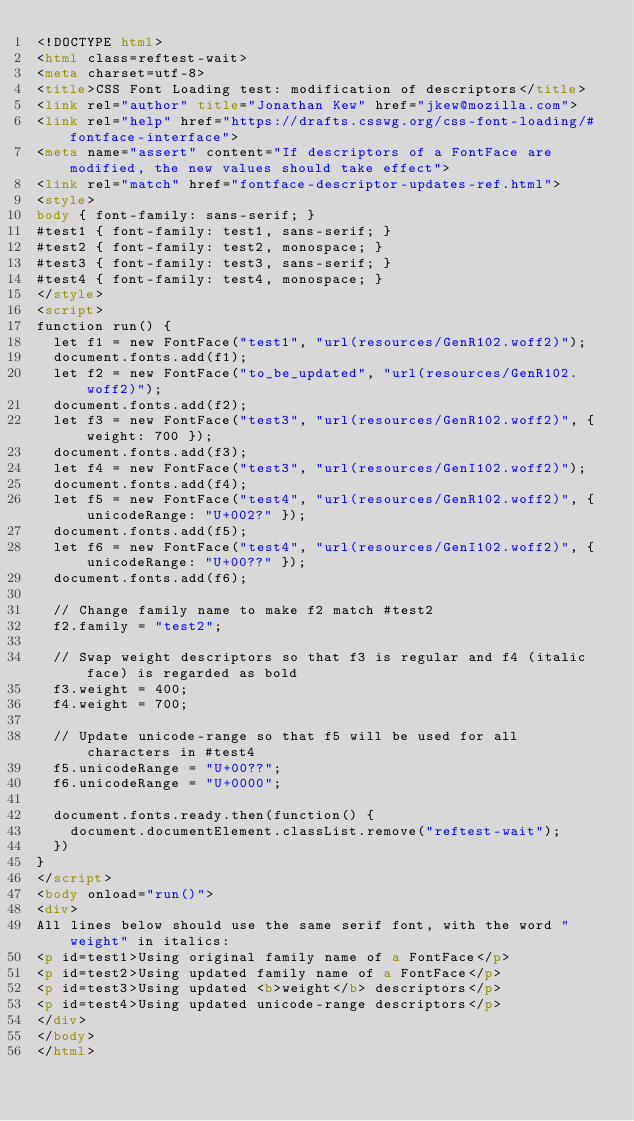<code> <loc_0><loc_0><loc_500><loc_500><_HTML_><!DOCTYPE html>
<html class=reftest-wait>
<meta charset=utf-8>
<title>CSS Font Loading test: modification of descriptors</title>
<link rel="author" title="Jonathan Kew" href="jkew@mozilla.com">
<link rel="help" href="https://drafts.csswg.org/css-font-loading/#fontface-interface">
<meta name="assert" content="If descriptors of a FontFace are modified, the new values should take effect">
<link rel="match" href="fontface-descriptor-updates-ref.html">
<style>
body { font-family: sans-serif; }
#test1 { font-family: test1, sans-serif; }
#test2 { font-family: test2, monospace; }
#test3 { font-family: test3, sans-serif; }
#test4 { font-family: test4, monospace; }
</style>
<script>
function run() {
  let f1 = new FontFace("test1", "url(resources/GenR102.woff2)");
  document.fonts.add(f1);
  let f2 = new FontFace("to_be_updated", "url(resources/GenR102.woff2)");
  document.fonts.add(f2);
  let f3 = new FontFace("test3", "url(resources/GenR102.woff2)", { weight: 700 });
  document.fonts.add(f3);
  let f4 = new FontFace("test3", "url(resources/GenI102.woff2)");
  document.fonts.add(f4);
  let f5 = new FontFace("test4", "url(resources/GenR102.woff2)", { unicodeRange: "U+002?" });
  document.fonts.add(f5);
  let f6 = new FontFace("test4", "url(resources/GenI102.woff2)", { unicodeRange: "U+00??" });
  document.fonts.add(f6);

  // Change family name to make f2 match #test2
  f2.family = "test2";

  // Swap weight descriptors so that f3 is regular and f4 (italic face) is regarded as bold
  f3.weight = 400;
  f4.weight = 700;

  // Update unicode-range so that f5 will be used for all characters in #test4
  f5.unicodeRange = "U+00??";
  f6.unicodeRange = "U+0000";

  document.fonts.ready.then(function() {
    document.documentElement.classList.remove("reftest-wait");
  })
}
</script>
<body onload="run()">
<div>
All lines below should use the same serif font, with the word "weight" in italics:
<p id=test1>Using original family name of a FontFace</p>
<p id=test2>Using updated family name of a FontFace</p>
<p id=test3>Using updated <b>weight</b> descriptors</p>
<p id=test4>Using updated unicode-range descriptors</p>
</div>
</body>
</html>
</code> 